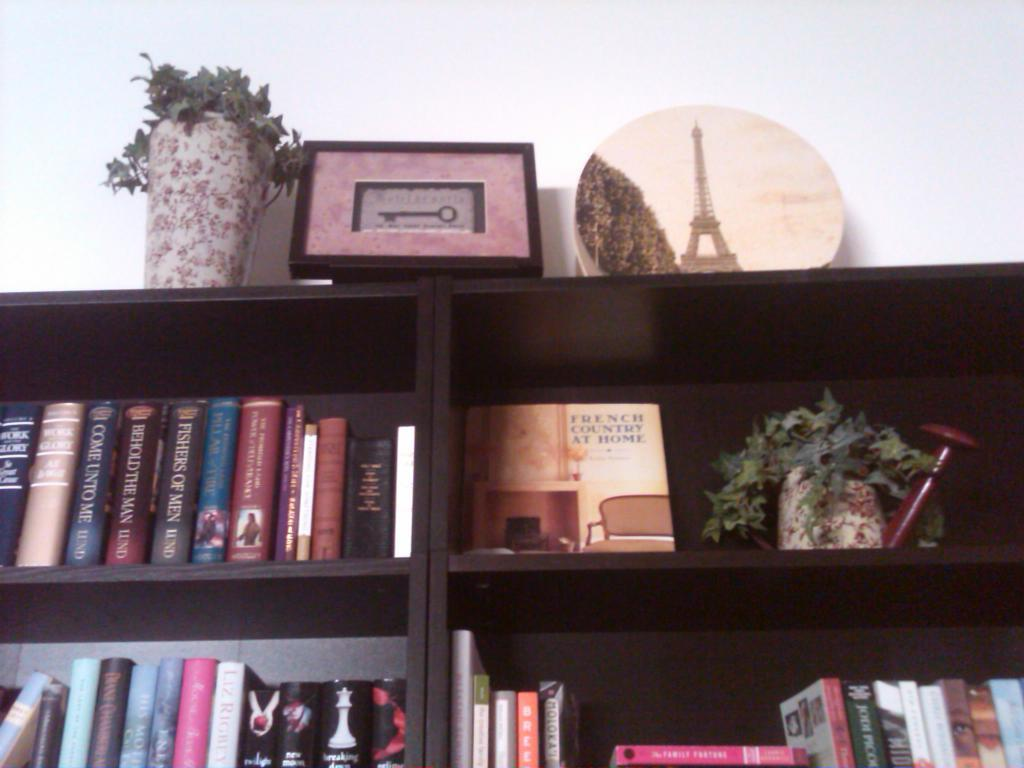<image>
Offer a succinct explanation of the picture presented. A wooden bookshelf with a vase on top and a plate picture of Eiffel tower. 